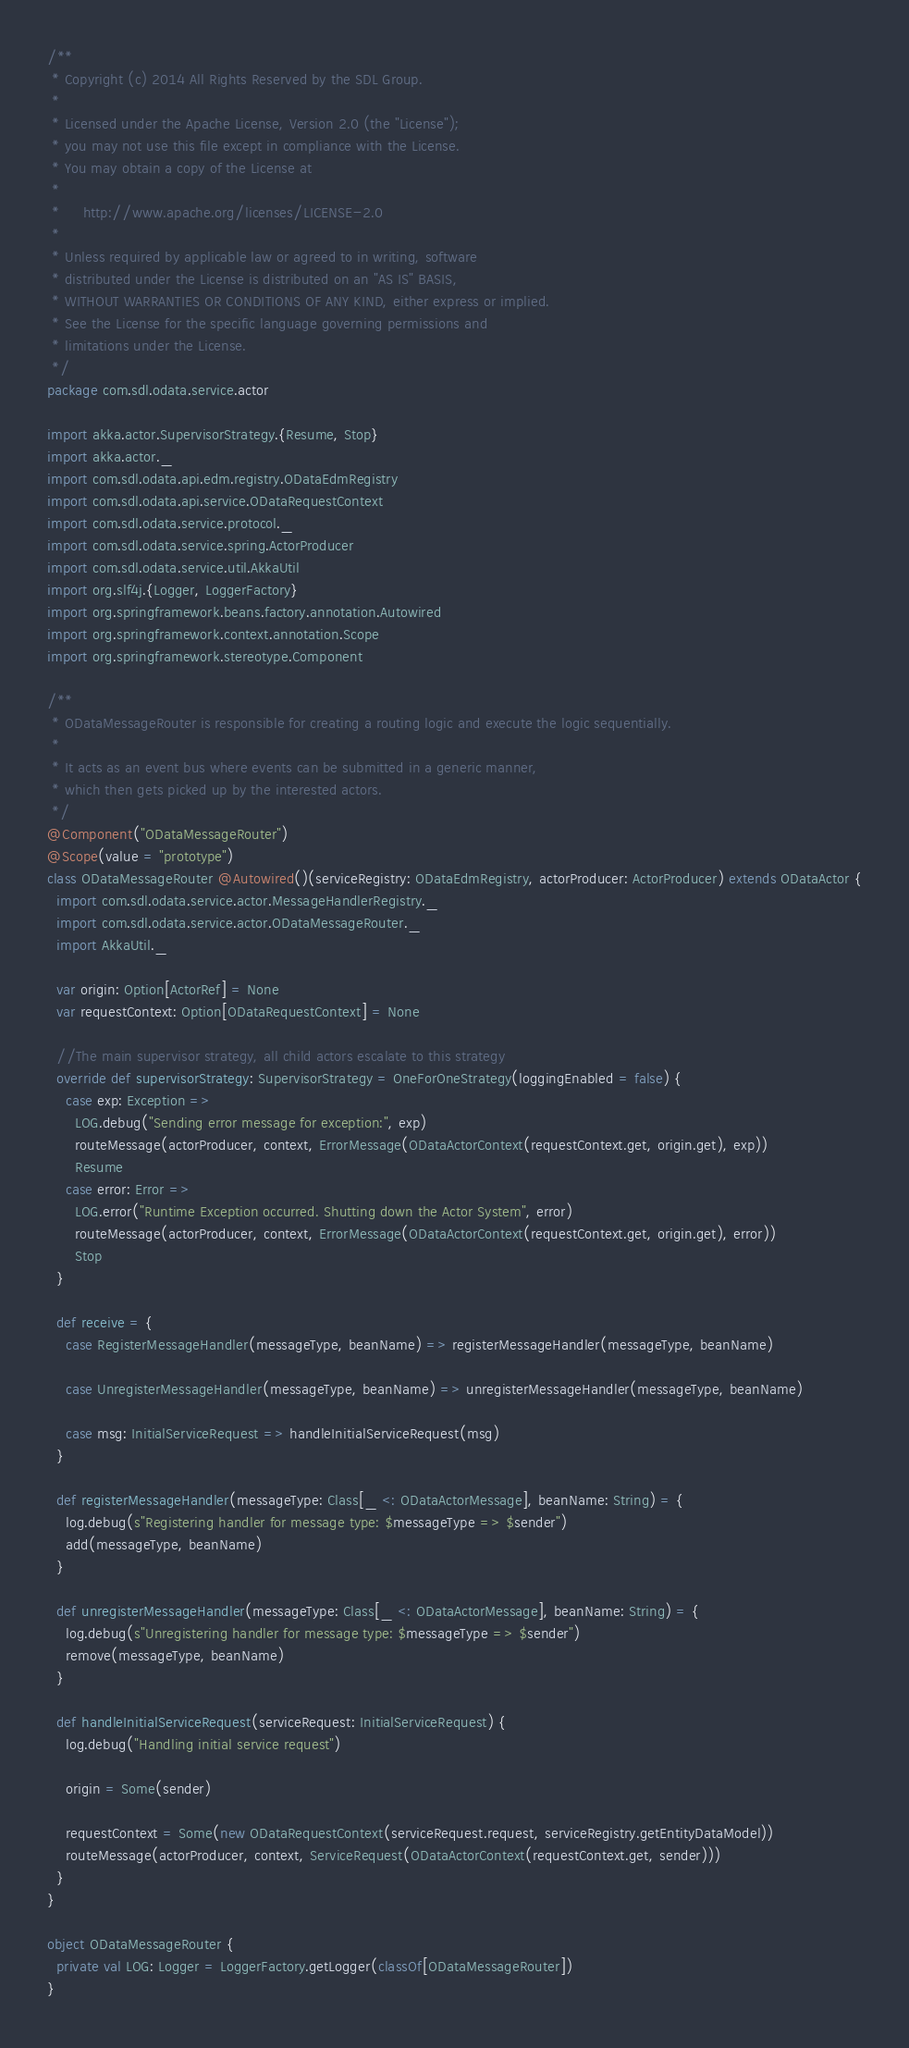<code> <loc_0><loc_0><loc_500><loc_500><_Scala_>/**
 * Copyright (c) 2014 All Rights Reserved by the SDL Group.
 *
 * Licensed under the Apache License, Version 2.0 (the "License");
 * you may not use this file except in compliance with the License.
 * You may obtain a copy of the License at
 *
 *     http://www.apache.org/licenses/LICENSE-2.0
 *
 * Unless required by applicable law or agreed to in writing, software
 * distributed under the License is distributed on an "AS IS" BASIS,
 * WITHOUT WARRANTIES OR CONDITIONS OF ANY KIND, either express or implied.
 * See the License for the specific language governing permissions and
 * limitations under the License.
 */
package com.sdl.odata.service.actor

import akka.actor.SupervisorStrategy.{Resume, Stop}
import akka.actor._
import com.sdl.odata.api.edm.registry.ODataEdmRegistry
import com.sdl.odata.api.service.ODataRequestContext
import com.sdl.odata.service.protocol._
import com.sdl.odata.service.spring.ActorProducer
import com.sdl.odata.service.util.AkkaUtil
import org.slf4j.{Logger, LoggerFactory}
import org.springframework.beans.factory.annotation.Autowired
import org.springframework.context.annotation.Scope
import org.springframework.stereotype.Component

/**
 * ODataMessageRouter is responsible for creating a routing logic and execute the logic sequentially.
 *
 * It acts as an event bus where events can be submitted in a generic manner,
 * which then gets picked up by the interested actors.
 */
@Component("ODataMessageRouter")
@Scope(value = "prototype")
class ODataMessageRouter @Autowired()(serviceRegistry: ODataEdmRegistry, actorProducer: ActorProducer) extends ODataActor {
  import com.sdl.odata.service.actor.MessageHandlerRegistry._
  import com.sdl.odata.service.actor.ODataMessageRouter._
  import AkkaUtil._

  var origin: Option[ActorRef] = None
  var requestContext: Option[ODataRequestContext] = None

  //The main supervisor strategy, all child actors escalate to this strategy
  override def supervisorStrategy: SupervisorStrategy = OneForOneStrategy(loggingEnabled = false) {
    case exp: Exception =>
      LOG.debug("Sending error message for exception:", exp)
      routeMessage(actorProducer, context, ErrorMessage(ODataActorContext(requestContext.get, origin.get), exp))
      Resume
    case error: Error =>
      LOG.error("Runtime Exception occurred. Shutting down the Actor System", error)
      routeMessage(actorProducer, context, ErrorMessage(ODataActorContext(requestContext.get, origin.get), error))
      Stop
  }

  def receive = {
    case RegisterMessageHandler(messageType, beanName) => registerMessageHandler(messageType, beanName)

    case UnregisterMessageHandler(messageType, beanName) => unregisterMessageHandler(messageType, beanName)

    case msg: InitialServiceRequest => handleInitialServiceRequest(msg)
  }

  def registerMessageHandler(messageType: Class[_ <: ODataActorMessage], beanName: String) = {
    log.debug(s"Registering handler for message type: $messageType => $sender")
    add(messageType, beanName)
  }

  def unregisterMessageHandler(messageType: Class[_ <: ODataActorMessage], beanName: String) = {
    log.debug(s"Unregistering handler for message type: $messageType => $sender")
    remove(messageType, beanName)
  }

  def handleInitialServiceRequest(serviceRequest: InitialServiceRequest) {
    log.debug("Handling initial service request")

    origin = Some(sender)

    requestContext = Some(new ODataRequestContext(serviceRequest.request, serviceRegistry.getEntityDataModel))
    routeMessage(actorProducer, context, ServiceRequest(ODataActorContext(requestContext.get, sender)))
  }
}

object ODataMessageRouter {
  private val LOG: Logger = LoggerFactory.getLogger(classOf[ODataMessageRouter])
}
</code> 